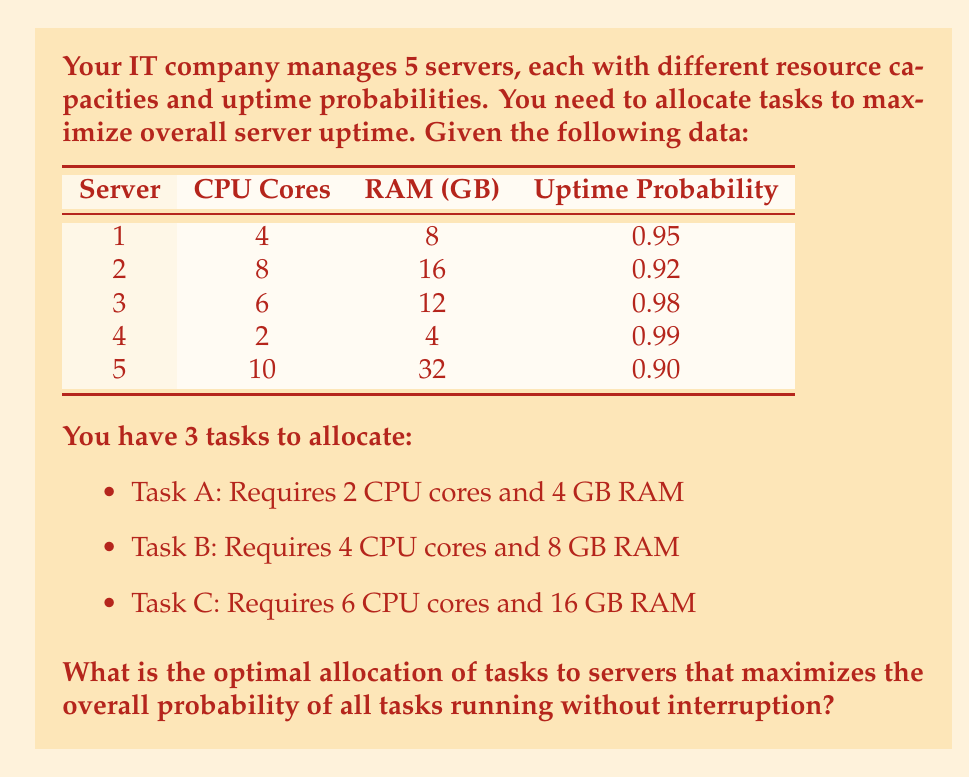Help me with this question. To solve this problem, we need to consider the resource requirements of each task and the capabilities of each server. We'll also need to calculate the probability of all tasks running without interruption for each possible allocation.

Step 1: Identify feasible allocations
- Task A can run on any server
- Task B can run on servers 1, 2, 3, and 5
- Task C can only run on servers 2 and 5

Step 2: List possible allocations
1. A on 4, B on 1, C on 2
2. A on 4, B on 1, C on 5
3. A on 4, B on 3, C on 2
4. A on 4, B on 3, C on 5
5. A on 1, B on 3, C on 2
6. A on 1, B on 3, C on 5

Step 3: Calculate the probability of all tasks running without interruption for each allocation
The probability of all tasks running is the product of the individual server probabilities:

1. $P_1 = 0.99 \times 0.95 \times 0.92 = 0.8651$
2. $P_2 = 0.99 \times 0.95 \times 0.90 = 0.8464$
3. $P_3 = 0.99 \times 0.98 \times 0.92 = 0.8915$
4. $P_4 = 0.99 \times 0.98 \times 0.90 = 0.8722$
5. $P_5 = 0.95 \times 0.98 \times 0.92 = 0.8556$
6. $P_6 = 0.95 \times 0.98 \times 0.90 = 0.8379$

Step 4: Identify the allocation with the highest probability
The highest probability is 0.8915, corresponding to allocation 3: A on server 4, B on server 3, and C on server 2.
Answer: The optimal allocation that maximizes the overall probability of all tasks running without interruption is:
Task A on Server 4
Task B on Server 3
Task C on Server 2

This allocation yields a probability of 0.8915 or approximately 89.15%. 